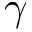Convert formula to latex. <formula><loc_0><loc_0><loc_500><loc_500>\gamma</formula> 